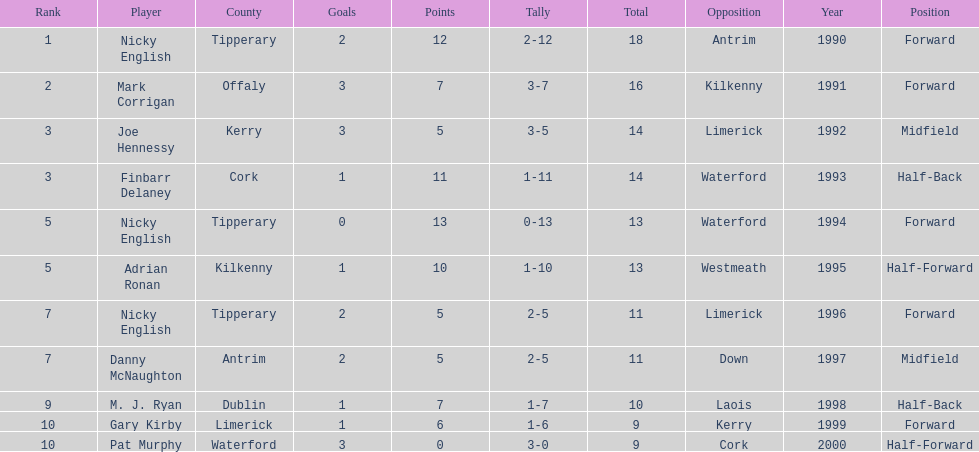Who ranked above mark corrigan? Nicky English. 